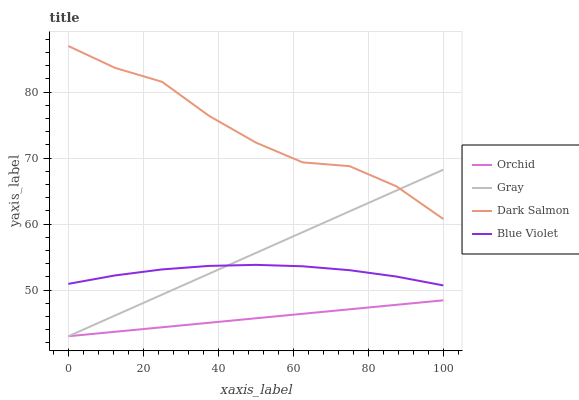Does Orchid have the minimum area under the curve?
Answer yes or no. Yes. Does Dark Salmon have the maximum area under the curve?
Answer yes or no. Yes. Does Blue Violet have the minimum area under the curve?
Answer yes or no. No. Does Blue Violet have the maximum area under the curve?
Answer yes or no. No. Is Orchid the smoothest?
Answer yes or no. Yes. Is Dark Salmon the roughest?
Answer yes or no. Yes. Is Blue Violet the smoothest?
Answer yes or no. No. Is Blue Violet the roughest?
Answer yes or no. No. Does Blue Violet have the lowest value?
Answer yes or no. No. Does Dark Salmon have the highest value?
Answer yes or no. Yes. Does Blue Violet have the highest value?
Answer yes or no. No. Is Orchid less than Dark Salmon?
Answer yes or no. Yes. Is Dark Salmon greater than Blue Violet?
Answer yes or no. Yes. Does Orchid intersect Gray?
Answer yes or no. Yes. Is Orchid less than Gray?
Answer yes or no. No. Is Orchid greater than Gray?
Answer yes or no. No. Does Orchid intersect Dark Salmon?
Answer yes or no. No. 